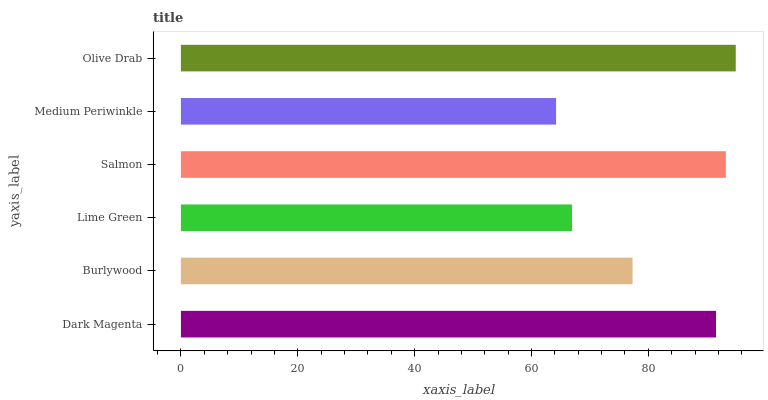Is Medium Periwinkle the minimum?
Answer yes or no. Yes. Is Olive Drab the maximum?
Answer yes or no. Yes. Is Burlywood the minimum?
Answer yes or no. No. Is Burlywood the maximum?
Answer yes or no. No. Is Dark Magenta greater than Burlywood?
Answer yes or no. Yes. Is Burlywood less than Dark Magenta?
Answer yes or no. Yes. Is Burlywood greater than Dark Magenta?
Answer yes or no. No. Is Dark Magenta less than Burlywood?
Answer yes or no. No. Is Dark Magenta the high median?
Answer yes or no. Yes. Is Burlywood the low median?
Answer yes or no. Yes. Is Lime Green the high median?
Answer yes or no. No. Is Lime Green the low median?
Answer yes or no. No. 